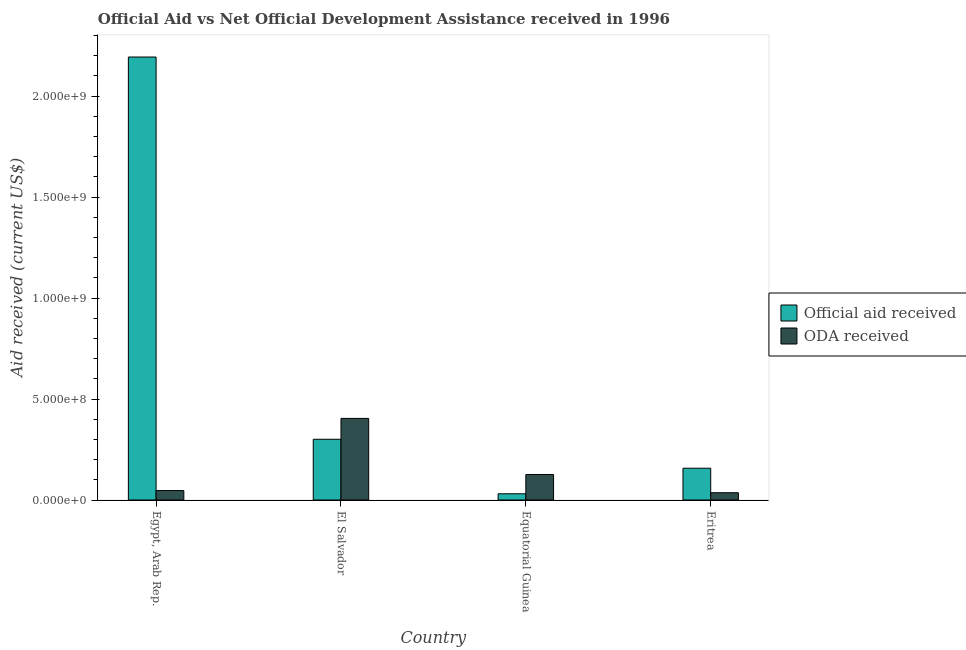How many groups of bars are there?
Give a very brief answer. 4. How many bars are there on the 1st tick from the left?
Your response must be concise. 2. How many bars are there on the 3rd tick from the right?
Your answer should be compact. 2. What is the label of the 1st group of bars from the left?
Provide a short and direct response. Egypt, Arab Rep. What is the oda received in Equatorial Guinea?
Keep it short and to the point. 1.26e+08. Across all countries, what is the maximum official aid received?
Your response must be concise. 2.19e+09. Across all countries, what is the minimum oda received?
Offer a terse response. 3.61e+07. In which country was the official aid received maximum?
Offer a very short reply. Egypt, Arab Rep. In which country was the official aid received minimum?
Provide a short and direct response. Equatorial Guinea. What is the total oda received in the graph?
Your answer should be compact. 6.13e+08. What is the difference between the official aid received in Egypt, Arab Rep. and that in Eritrea?
Give a very brief answer. 2.04e+09. What is the difference between the oda received in Equatorial Guinea and the official aid received in El Salvador?
Provide a short and direct response. -1.74e+08. What is the average oda received per country?
Provide a succinct answer. 1.53e+08. What is the difference between the official aid received and oda received in Equatorial Guinea?
Your answer should be very brief. -9.55e+07. In how many countries, is the oda received greater than 1700000000 US$?
Your answer should be compact. 0. What is the ratio of the oda received in Egypt, Arab Rep. to that in Equatorial Guinea?
Provide a short and direct response. 0.37. Is the oda received in Egypt, Arab Rep. less than that in Eritrea?
Offer a very short reply. No. Is the difference between the oda received in El Salvador and Eritrea greater than the difference between the official aid received in El Salvador and Eritrea?
Ensure brevity in your answer.  Yes. What is the difference between the highest and the second highest oda received?
Provide a short and direct response. 2.78e+08. What is the difference between the highest and the lowest oda received?
Your answer should be very brief. 3.68e+08. What does the 2nd bar from the left in El Salvador represents?
Offer a very short reply. ODA received. What does the 1st bar from the right in Egypt, Arab Rep. represents?
Give a very brief answer. ODA received. How many countries are there in the graph?
Give a very brief answer. 4. What is the difference between two consecutive major ticks on the Y-axis?
Ensure brevity in your answer.  5.00e+08. Does the graph contain any zero values?
Make the answer very short. No. How are the legend labels stacked?
Offer a very short reply. Vertical. What is the title of the graph?
Give a very brief answer. Official Aid vs Net Official Development Assistance received in 1996 . Does "Primary school" appear as one of the legend labels in the graph?
Your response must be concise. No. What is the label or title of the Y-axis?
Your answer should be very brief. Aid received (current US$). What is the Aid received (current US$) of Official aid received in Egypt, Arab Rep.?
Provide a short and direct response. 2.19e+09. What is the Aid received (current US$) in ODA received in Egypt, Arab Rep.?
Make the answer very short. 4.68e+07. What is the Aid received (current US$) of Official aid received in El Salvador?
Offer a very short reply. 3.01e+08. What is the Aid received (current US$) in ODA received in El Salvador?
Your response must be concise. 4.04e+08. What is the Aid received (current US$) of Official aid received in Equatorial Guinea?
Offer a very short reply. 3.08e+07. What is the Aid received (current US$) in ODA received in Equatorial Guinea?
Give a very brief answer. 1.26e+08. What is the Aid received (current US$) in Official aid received in Eritrea?
Keep it short and to the point. 1.57e+08. What is the Aid received (current US$) of ODA received in Eritrea?
Your answer should be very brief. 3.61e+07. Across all countries, what is the maximum Aid received (current US$) in Official aid received?
Your response must be concise. 2.19e+09. Across all countries, what is the maximum Aid received (current US$) of ODA received?
Provide a short and direct response. 4.04e+08. Across all countries, what is the minimum Aid received (current US$) in Official aid received?
Keep it short and to the point. 3.08e+07. Across all countries, what is the minimum Aid received (current US$) in ODA received?
Your answer should be compact. 3.61e+07. What is the total Aid received (current US$) of Official aid received in the graph?
Give a very brief answer. 2.68e+09. What is the total Aid received (current US$) of ODA received in the graph?
Offer a very short reply. 6.13e+08. What is the difference between the Aid received (current US$) of Official aid received in Egypt, Arab Rep. and that in El Salvador?
Give a very brief answer. 1.89e+09. What is the difference between the Aid received (current US$) of ODA received in Egypt, Arab Rep. and that in El Salvador?
Offer a very short reply. -3.57e+08. What is the difference between the Aid received (current US$) in Official aid received in Egypt, Arab Rep. and that in Equatorial Guinea?
Offer a very short reply. 2.16e+09. What is the difference between the Aid received (current US$) of ODA received in Egypt, Arab Rep. and that in Equatorial Guinea?
Give a very brief answer. -7.95e+07. What is the difference between the Aid received (current US$) of Official aid received in Egypt, Arab Rep. and that in Eritrea?
Your answer should be very brief. 2.04e+09. What is the difference between the Aid received (current US$) in ODA received in Egypt, Arab Rep. and that in Eritrea?
Your response must be concise. 1.07e+07. What is the difference between the Aid received (current US$) of Official aid received in El Salvador and that in Equatorial Guinea?
Offer a terse response. 2.70e+08. What is the difference between the Aid received (current US$) of ODA received in El Salvador and that in Equatorial Guinea?
Make the answer very short. 2.78e+08. What is the difference between the Aid received (current US$) in Official aid received in El Salvador and that in Eritrea?
Your answer should be very brief. 1.43e+08. What is the difference between the Aid received (current US$) of ODA received in El Salvador and that in Eritrea?
Keep it short and to the point. 3.68e+08. What is the difference between the Aid received (current US$) of Official aid received in Equatorial Guinea and that in Eritrea?
Ensure brevity in your answer.  -1.27e+08. What is the difference between the Aid received (current US$) in ODA received in Equatorial Guinea and that in Eritrea?
Your response must be concise. 9.02e+07. What is the difference between the Aid received (current US$) in Official aid received in Egypt, Arab Rep. and the Aid received (current US$) in ODA received in El Salvador?
Your answer should be compact. 1.79e+09. What is the difference between the Aid received (current US$) of Official aid received in Egypt, Arab Rep. and the Aid received (current US$) of ODA received in Equatorial Guinea?
Provide a succinct answer. 2.07e+09. What is the difference between the Aid received (current US$) in Official aid received in Egypt, Arab Rep. and the Aid received (current US$) in ODA received in Eritrea?
Offer a terse response. 2.16e+09. What is the difference between the Aid received (current US$) in Official aid received in El Salvador and the Aid received (current US$) in ODA received in Equatorial Guinea?
Keep it short and to the point. 1.74e+08. What is the difference between the Aid received (current US$) in Official aid received in El Salvador and the Aid received (current US$) in ODA received in Eritrea?
Your answer should be compact. 2.65e+08. What is the difference between the Aid received (current US$) in Official aid received in Equatorial Guinea and the Aid received (current US$) in ODA received in Eritrea?
Your answer should be very brief. -5.24e+06. What is the average Aid received (current US$) of Official aid received per country?
Make the answer very short. 6.71e+08. What is the average Aid received (current US$) in ODA received per country?
Offer a terse response. 1.53e+08. What is the difference between the Aid received (current US$) in Official aid received and Aid received (current US$) in ODA received in Egypt, Arab Rep.?
Offer a very short reply. 2.15e+09. What is the difference between the Aid received (current US$) in Official aid received and Aid received (current US$) in ODA received in El Salvador?
Your answer should be compact. -1.03e+08. What is the difference between the Aid received (current US$) of Official aid received and Aid received (current US$) of ODA received in Equatorial Guinea?
Your response must be concise. -9.55e+07. What is the difference between the Aid received (current US$) in Official aid received and Aid received (current US$) in ODA received in Eritrea?
Your answer should be compact. 1.21e+08. What is the ratio of the Aid received (current US$) in Official aid received in Egypt, Arab Rep. to that in El Salvador?
Your answer should be very brief. 7.29. What is the ratio of the Aid received (current US$) of ODA received in Egypt, Arab Rep. to that in El Salvador?
Provide a short and direct response. 0.12. What is the ratio of the Aid received (current US$) in Official aid received in Egypt, Arab Rep. to that in Equatorial Guinea?
Offer a very short reply. 71.19. What is the ratio of the Aid received (current US$) in ODA received in Egypt, Arab Rep. to that in Equatorial Guinea?
Your answer should be compact. 0.37. What is the ratio of the Aid received (current US$) in Official aid received in Egypt, Arab Rep. to that in Eritrea?
Provide a short and direct response. 13.93. What is the ratio of the Aid received (current US$) in ODA received in Egypt, Arab Rep. to that in Eritrea?
Offer a terse response. 1.3. What is the ratio of the Aid received (current US$) in Official aid received in El Salvador to that in Equatorial Guinea?
Ensure brevity in your answer.  9.76. What is the ratio of the Aid received (current US$) of ODA received in El Salvador to that in Equatorial Guinea?
Provide a short and direct response. 3.2. What is the ratio of the Aid received (current US$) in Official aid received in El Salvador to that in Eritrea?
Provide a succinct answer. 1.91. What is the ratio of the Aid received (current US$) of ODA received in El Salvador to that in Eritrea?
Ensure brevity in your answer.  11.21. What is the ratio of the Aid received (current US$) in Official aid received in Equatorial Guinea to that in Eritrea?
Offer a very short reply. 0.2. What is the ratio of the Aid received (current US$) of ODA received in Equatorial Guinea to that in Eritrea?
Keep it short and to the point. 3.5. What is the difference between the highest and the second highest Aid received (current US$) in Official aid received?
Provide a short and direct response. 1.89e+09. What is the difference between the highest and the second highest Aid received (current US$) of ODA received?
Provide a short and direct response. 2.78e+08. What is the difference between the highest and the lowest Aid received (current US$) in Official aid received?
Your response must be concise. 2.16e+09. What is the difference between the highest and the lowest Aid received (current US$) of ODA received?
Ensure brevity in your answer.  3.68e+08. 